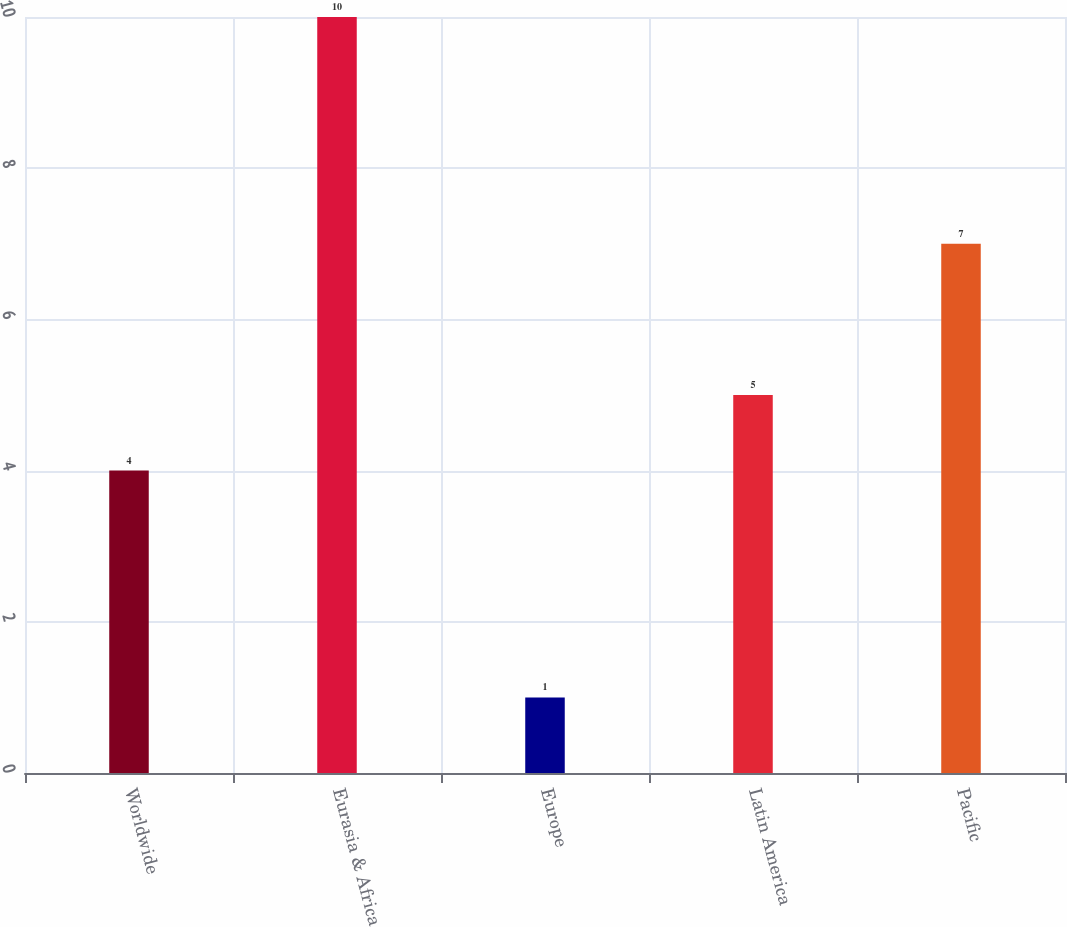Convert chart. <chart><loc_0><loc_0><loc_500><loc_500><bar_chart><fcel>Worldwide<fcel>Eurasia & Africa<fcel>Europe<fcel>Latin America<fcel>Pacific<nl><fcel>4<fcel>10<fcel>1<fcel>5<fcel>7<nl></chart> 